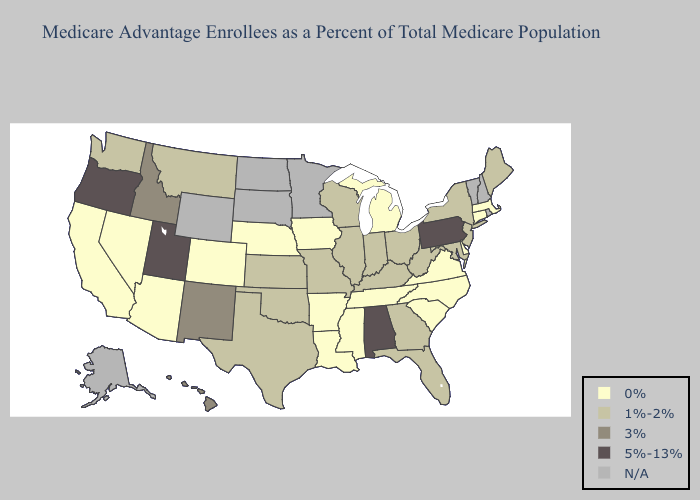Does West Virginia have the lowest value in the South?
Give a very brief answer. No. Name the states that have a value in the range 5%-13%?
Concise answer only. Alabama, Oregon, Pennsylvania, Utah. Name the states that have a value in the range 3%?
Concise answer only. Hawaii, Idaho, New Mexico. Which states have the lowest value in the South?
Short answer required. Arkansas, Delaware, Louisiana, Mississippi, North Carolina, South Carolina, Tennessee, Virginia. What is the value of Arkansas?
Concise answer only. 0%. Name the states that have a value in the range 3%?
Be succinct. Hawaii, Idaho, New Mexico. What is the lowest value in states that border Indiana?
Give a very brief answer. 0%. What is the highest value in states that border Idaho?
Write a very short answer. 5%-13%. What is the highest value in the USA?
Answer briefly. 5%-13%. Which states have the lowest value in the USA?
Keep it brief. Arkansas, Arizona, California, Colorado, Connecticut, Delaware, Iowa, Louisiana, Massachusetts, Michigan, Mississippi, North Carolina, Nebraska, Nevada, South Carolina, Tennessee, Virginia. Name the states that have a value in the range 0%?
Be succinct. Arkansas, Arizona, California, Colorado, Connecticut, Delaware, Iowa, Louisiana, Massachusetts, Michigan, Mississippi, North Carolina, Nebraska, Nevada, South Carolina, Tennessee, Virginia. Among the states that border Texas , which have the lowest value?
Concise answer only. Arkansas, Louisiana. What is the value of Utah?
Write a very short answer. 5%-13%. Among the states that border Oklahoma , which have the highest value?
Be succinct. New Mexico. 